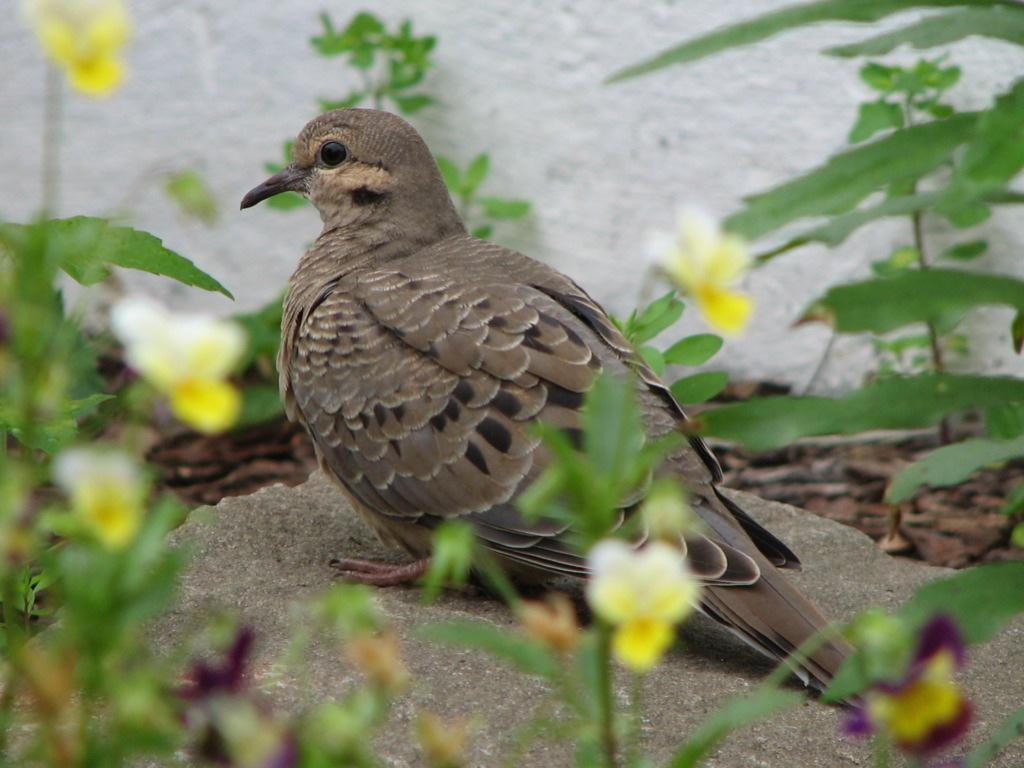What is the main subject of the image? There is a bird standing on a rock in the image. What other elements can be seen in the image? There are plants with flowers in the image. What is visible in the background of the image? There is a wall in the background of the image. What color is the wall? The wall is white in color. How many boys are playing on the amusement ride in the image? There are no boys or amusement rides present in the image. What type of shoes can be seen on the bird in the image? There are no shoes visible in the image, as it features a bird standing on a rock. 